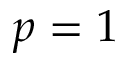<formula> <loc_0><loc_0><loc_500><loc_500>p = 1</formula> 